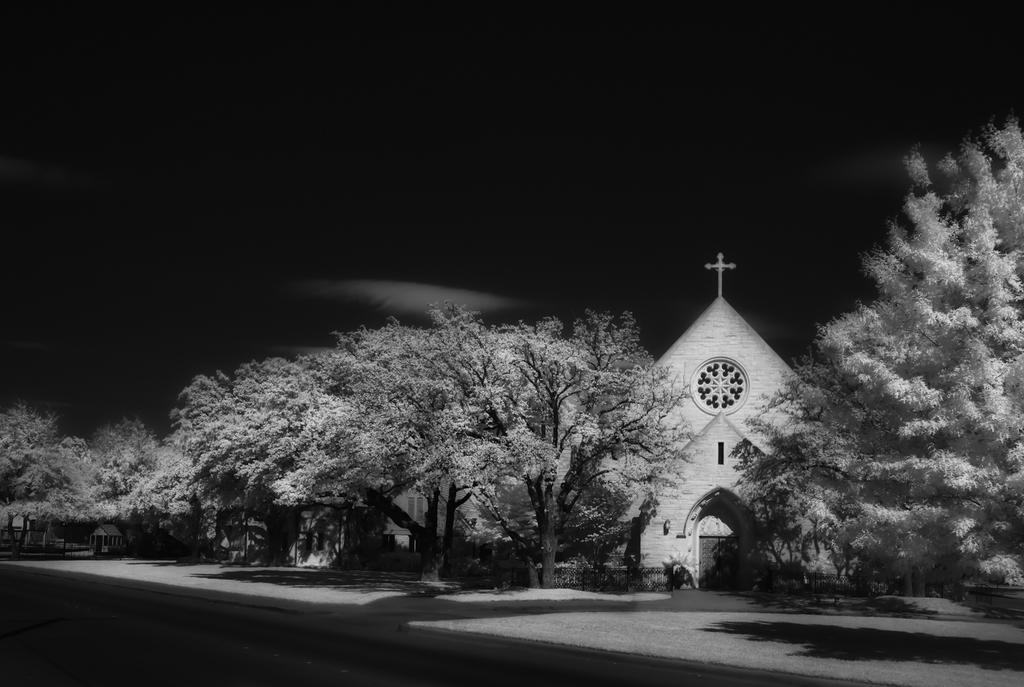Can you describe this image briefly? In this image, we can see so many trees, houses with walls. Here we can see doors and windows. At the bottom, there is a road. Background there is a dark view. Here we can see a holy cross on the top of the house. 